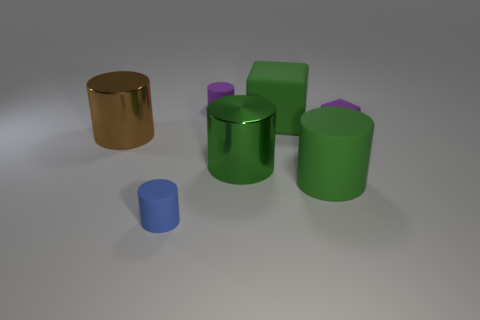Subtract all brown cylinders. How many cylinders are left? 4 Subtract all purple cylinders. How many cylinders are left? 4 Subtract all gray cylinders. Subtract all green blocks. How many cylinders are left? 5 Add 2 purple shiny cylinders. How many objects exist? 9 Subtract all cubes. How many objects are left? 5 Subtract 0 yellow balls. How many objects are left? 7 Subtract all small gray matte cylinders. Subtract all brown cylinders. How many objects are left? 6 Add 6 green matte cylinders. How many green matte cylinders are left? 7 Add 2 large brown shiny cylinders. How many large brown shiny cylinders exist? 3 